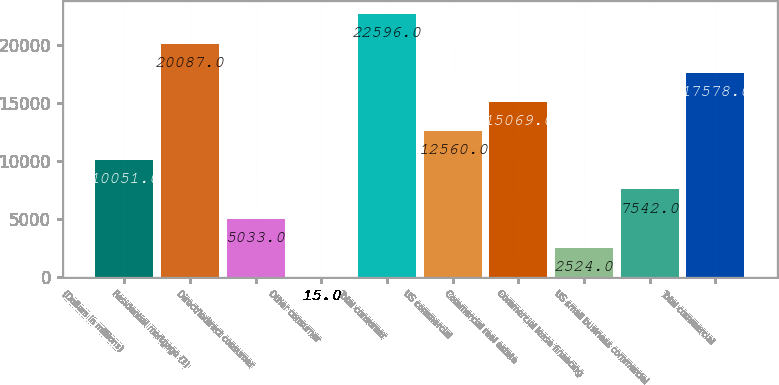Convert chart. <chart><loc_0><loc_0><loc_500><loc_500><bar_chart><fcel>(Dollars in millions)<fcel>Residential mortgage (1)<fcel>Direct/Indirect consumer<fcel>Other consumer<fcel>Total consumer<fcel>US commercial<fcel>Commercial real estate<fcel>Commercial lease financing<fcel>US small business commercial<fcel>Total commercial<nl><fcel>10051<fcel>20087<fcel>5033<fcel>15<fcel>22596<fcel>12560<fcel>15069<fcel>2524<fcel>7542<fcel>17578<nl></chart> 